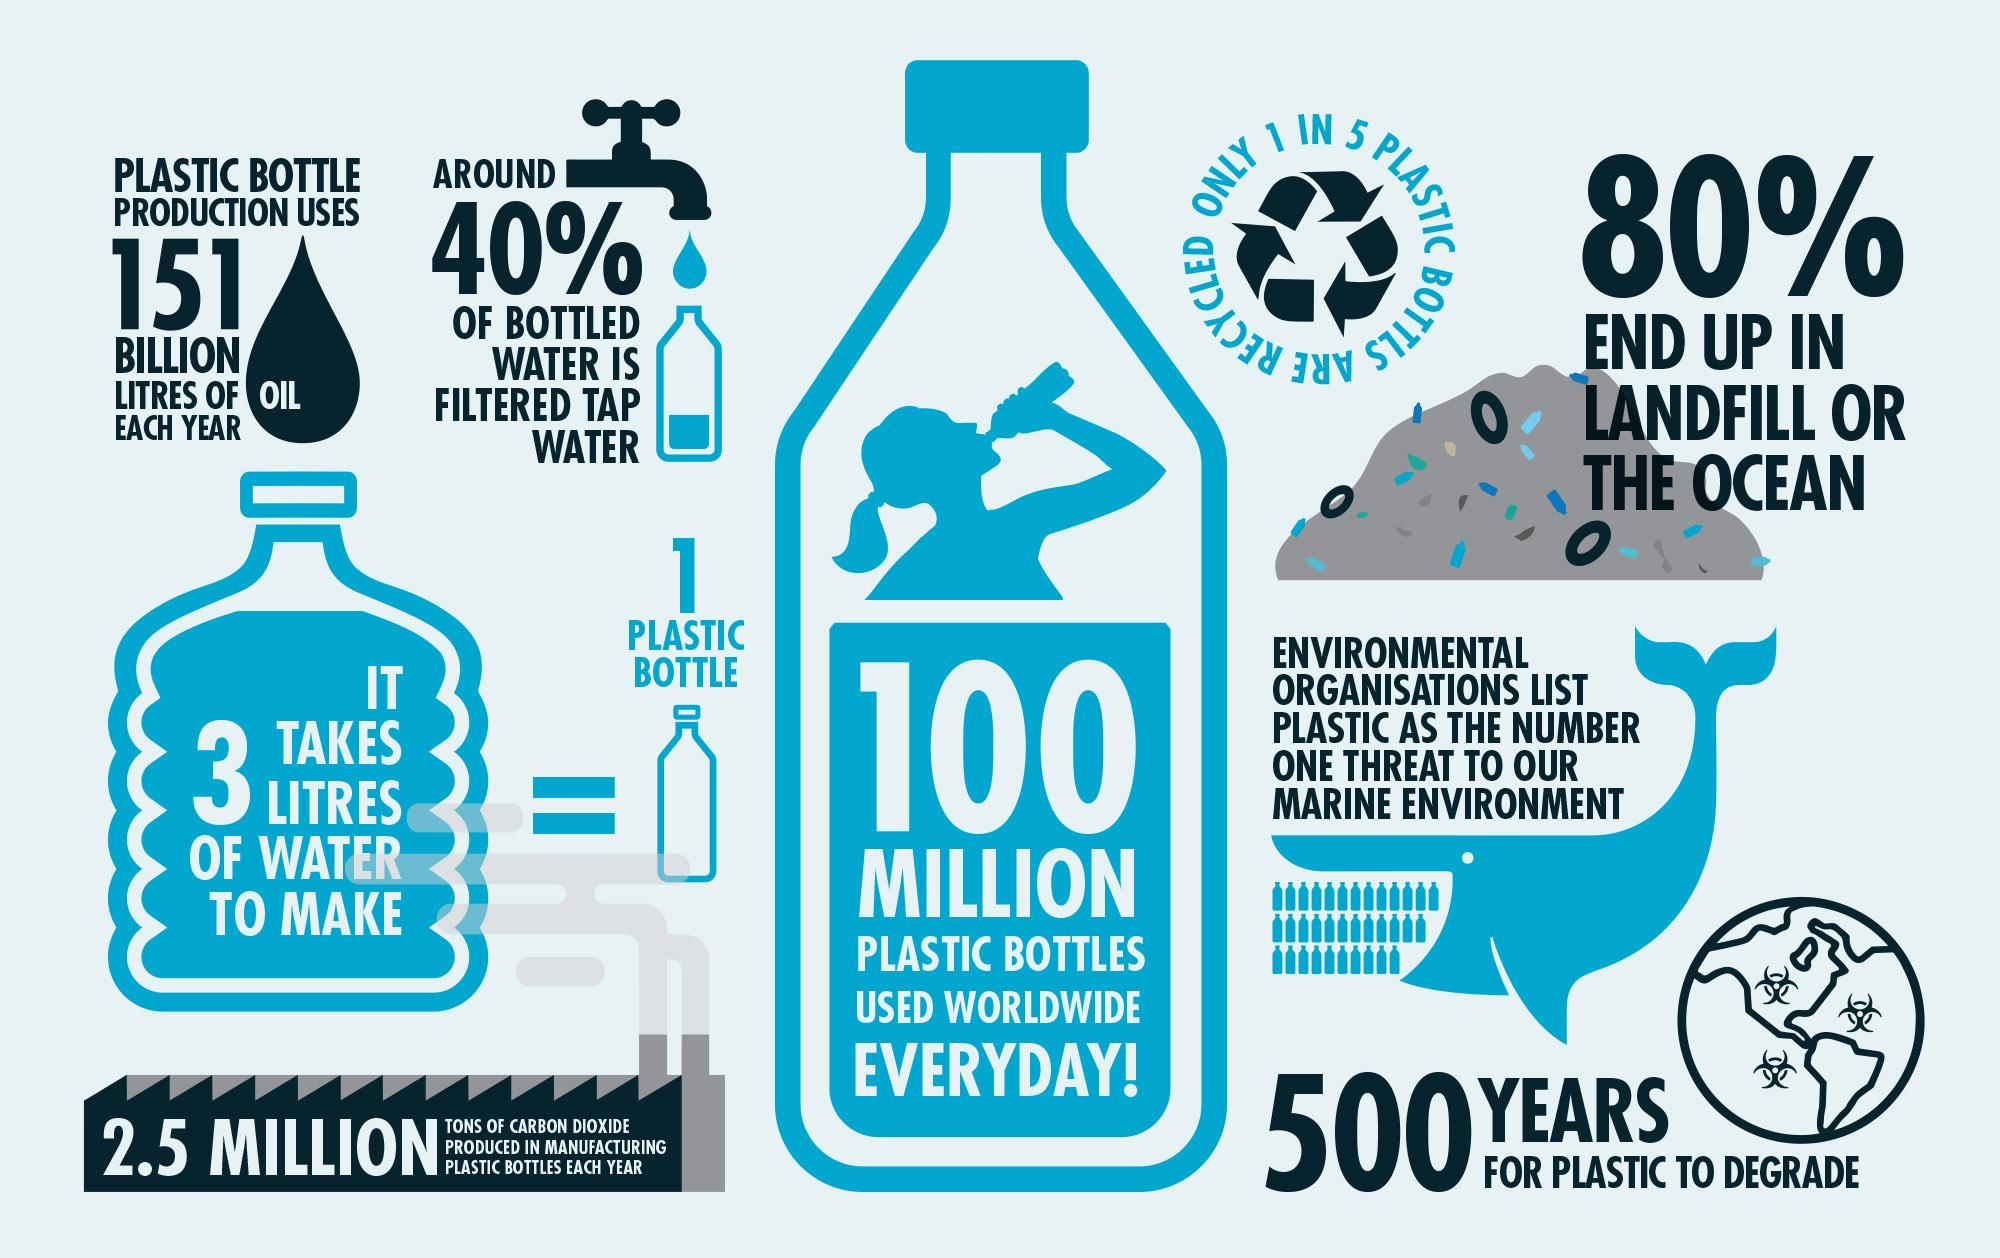Draw attention to some important aspects in this diagram. According to a recent study, 60% of bottled water is not filtered tap water, suggesting that many consumers are paying for a product that could be obtained for free from their tap. Every day, approximately 100 million plastic bottles are used worldwide. Out of 5, only 1 plastic bottle was recycled, the remaining 4 were not recycled. 